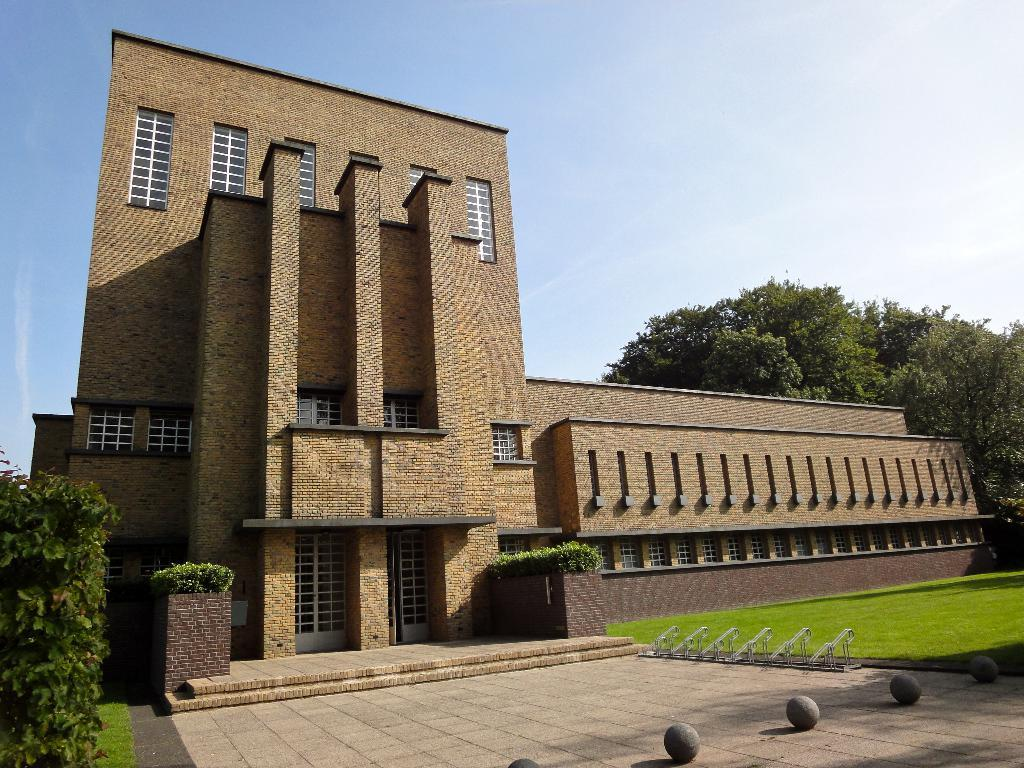What type of view is shown in the image? The image has an outside view. What structure is located in the foreground of the image? There is a building in the foreground of the image. What type of vegetation is on the right side of the image? There is a tree on the right side of the image. What is visible in the background of the image? There is a sky visible in the background of the image. What book is the tree reading in the image? There is no book present in the image, as trees do not have the ability to read. 